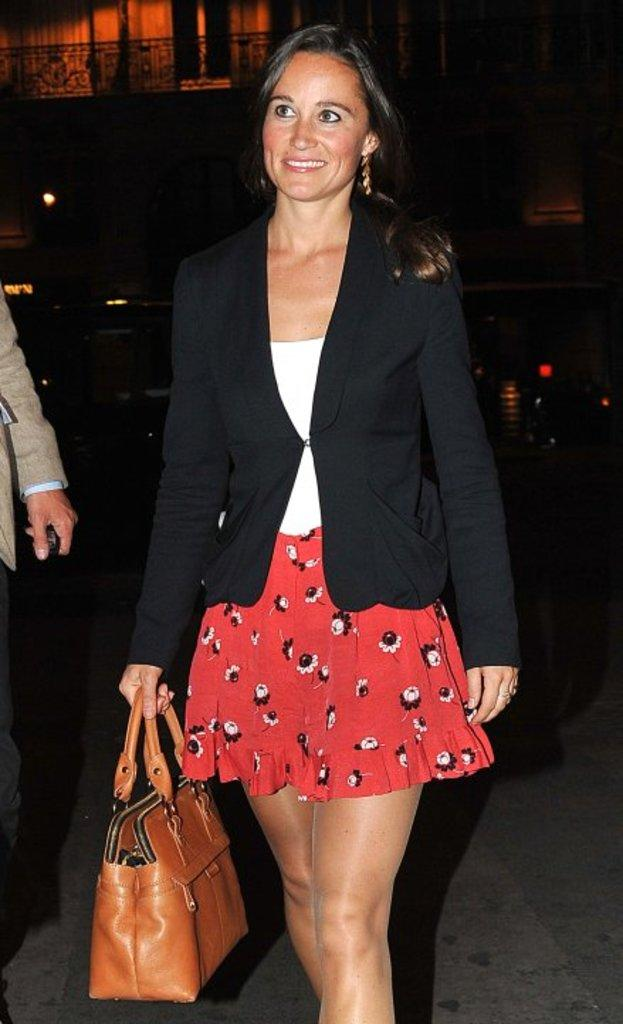Who is the main subject in the image? There is a woman in the image. What is the woman holding in her hand? The woman is holding a bag in her hand. What is the woman doing in the image? The woman is walking. Can you describe the person beside the woman? There is a person beside the woman, but no specific details are provided about them. What type of oil can be seen dripping from the woman's thumb in the image? There is no oil or thumb visible in the image; the woman is holding a bag in her hand. 